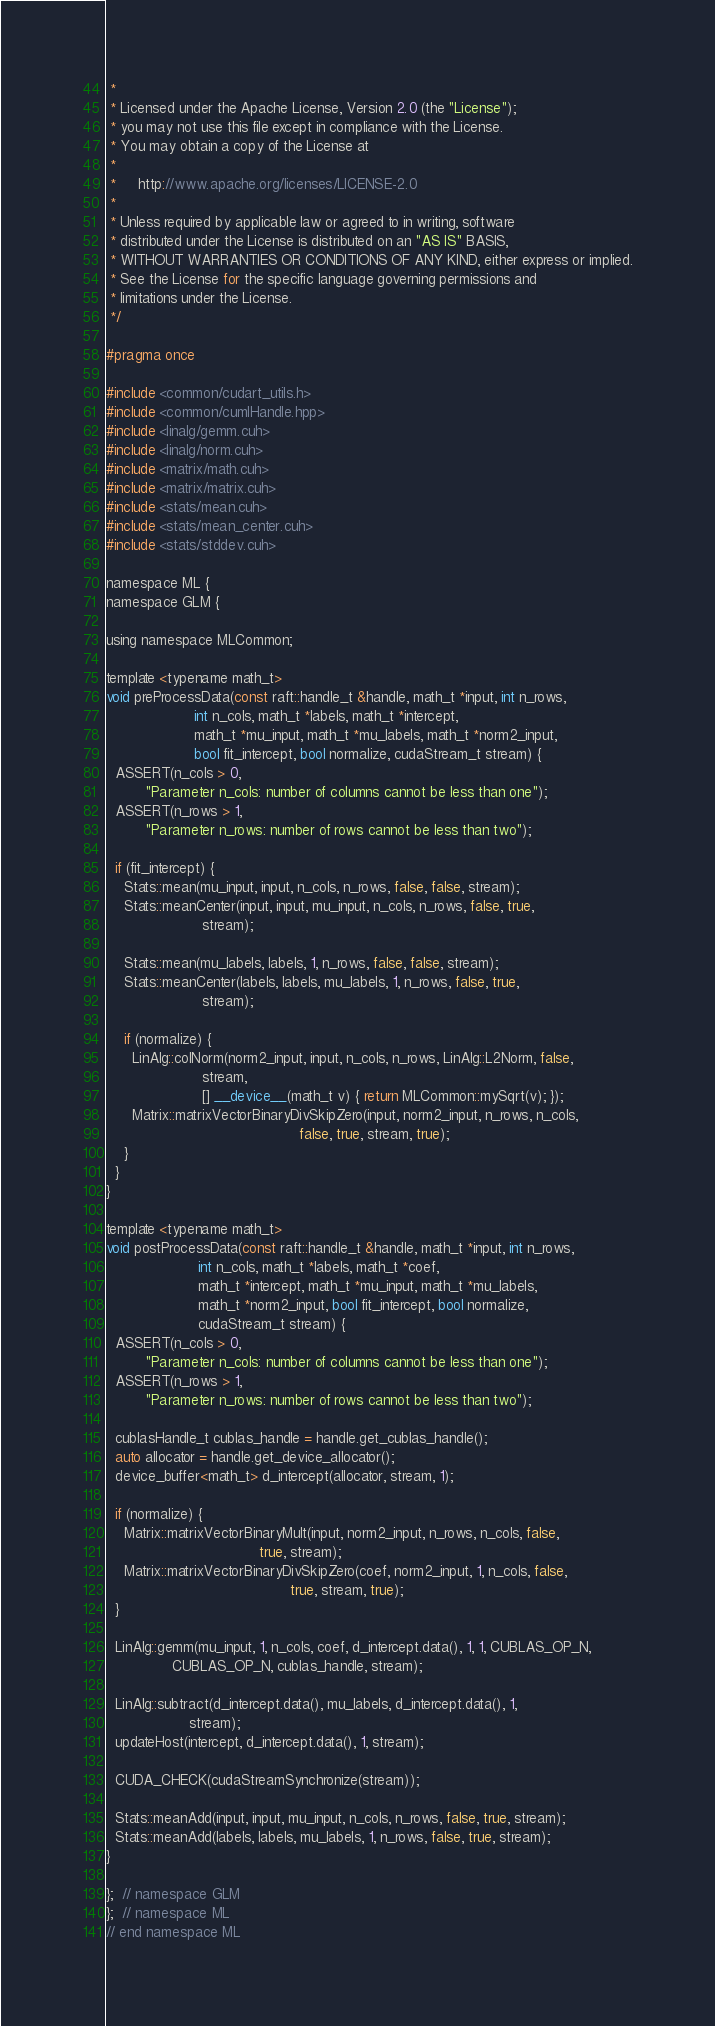Convert code to text. <code><loc_0><loc_0><loc_500><loc_500><_Cuda_> *
 * Licensed under the Apache License, Version 2.0 (the "License");
 * you may not use this file except in compliance with the License.
 * You may obtain a copy of the License at
 *
 *     http://www.apache.org/licenses/LICENSE-2.0
 *
 * Unless required by applicable law or agreed to in writing, software
 * distributed under the License is distributed on an "AS IS" BASIS,
 * WITHOUT WARRANTIES OR CONDITIONS OF ANY KIND, either express or implied.
 * See the License for the specific language governing permissions and
 * limitations under the License.
 */

#pragma once

#include <common/cudart_utils.h>
#include <common/cumlHandle.hpp>
#include <linalg/gemm.cuh>
#include <linalg/norm.cuh>
#include <matrix/math.cuh>
#include <matrix/matrix.cuh>
#include <stats/mean.cuh>
#include <stats/mean_center.cuh>
#include <stats/stddev.cuh>

namespace ML {
namespace GLM {

using namespace MLCommon;

template <typename math_t>
void preProcessData(const raft::handle_t &handle, math_t *input, int n_rows,
                    int n_cols, math_t *labels, math_t *intercept,
                    math_t *mu_input, math_t *mu_labels, math_t *norm2_input,
                    bool fit_intercept, bool normalize, cudaStream_t stream) {
  ASSERT(n_cols > 0,
         "Parameter n_cols: number of columns cannot be less than one");
  ASSERT(n_rows > 1,
         "Parameter n_rows: number of rows cannot be less than two");

  if (fit_intercept) {
    Stats::mean(mu_input, input, n_cols, n_rows, false, false, stream);
    Stats::meanCenter(input, input, mu_input, n_cols, n_rows, false, true,
                      stream);

    Stats::mean(mu_labels, labels, 1, n_rows, false, false, stream);
    Stats::meanCenter(labels, labels, mu_labels, 1, n_rows, false, true,
                      stream);

    if (normalize) {
      LinAlg::colNorm(norm2_input, input, n_cols, n_rows, LinAlg::L2Norm, false,
                      stream,
                      [] __device__(math_t v) { return MLCommon::mySqrt(v); });
      Matrix::matrixVectorBinaryDivSkipZero(input, norm2_input, n_rows, n_cols,
                                            false, true, stream, true);
    }
  }
}

template <typename math_t>
void postProcessData(const raft::handle_t &handle, math_t *input, int n_rows,
                     int n_cols, math_t *labels, math_t *coef,
                     math_t *intercept, math_t *mu_input, math_t *mu_labels,
                     math_t *norm2_input, bool fit_intercept, bool normalize,
                     cudaStream_t stream) {
  ASSERT(n_cols > 0,
         "Parameter n_cols: number of columns cannot be less than one");
  ASSERT(n_rows > 1,
         "Parameter n_rows: number of rows cannot be less than two");

  cublasHandle_t cublas_handle = handle.get_cublas_handle();
  auto allocator = handle.get_device_allocator();
  device_buffer<math_t> d_intercept(allocator, stream, 1);

  if (normalize) {
    Matrix::matrixVectorBinaryMult(input, norm2_input, n_rows, n_cols, false,
                                   true, stream);
    Matrix::matrixVectorBinaryDivSkipZero(coef, norm2_input, 1, n_cols, false,
                                          true, stream, true);
  }

  LinAlg::gemm(mu_input, 1, n_cols, coef, d_intercept.data(), 1, 1, CUBLAS_OP_N,
               CUBLAS_OP_N, cublas_handle, stream);

  LinAlg::subtract(d_intercept.data(), mu_labels, d_intercept.data(), 1,
                   stream);
  updateHost(intercept, d_intercept.data(), 1, stream);

  CUDA_CHECK(cudaStreamSynchronize(stream));

  Stats::meanAdd(input, input, mu_input, n_cols, n_rows, false, true, stream);
  Stats::meanAdd(labels, labels, mu_labels, 1, n_rows, false, true, stream);
}

};  // namespace GLM
};  // namespace ML
// end namespace ML
</code> 